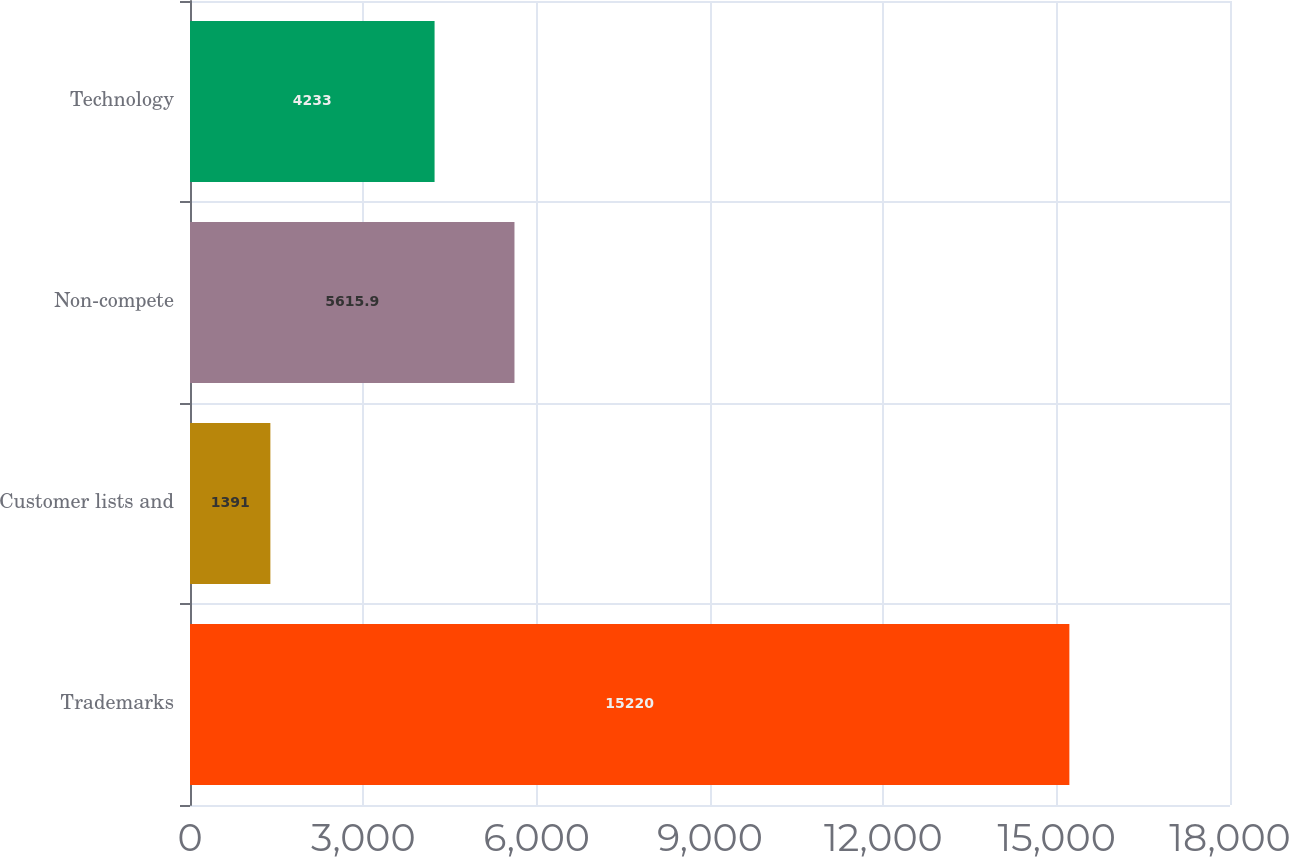Convert chart to OTSL. <chart><loc_0><loc_0><loc_500><loc_500><bar_chart><fcel>Trademarks<fcel>Customer lists and<fcel>Non-compete<fcel>Technology<nl><fcel>15220<fcel>1391<fcel>5615.9<fcel>4233<nl></chart> 